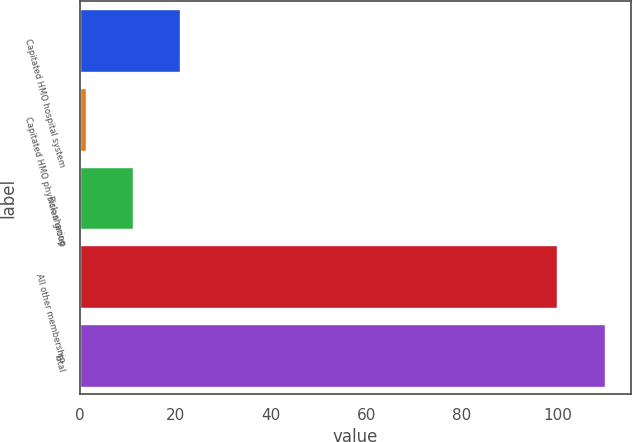Convert chart to OTSL. <chart><loc_0><loc_0><loc_500><loc_500><bar_chart><fcel>Capitated HMO hospital system<fcel>Capitated HMO physician group<fcel>Risk-sharing<fcel>All other membership<fcel>Total<nl><fcel>21.11<fcel>1.39<fcel>11.25<fcel>100<fcel>109.86<nl></chart> 